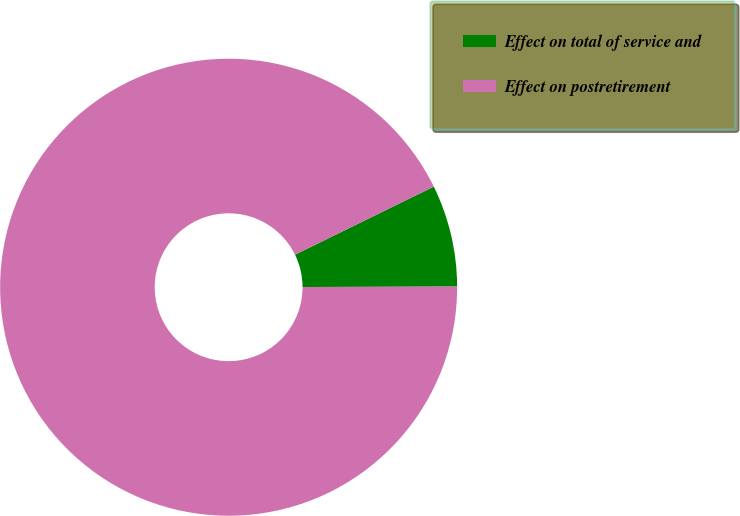Convert chart. <chart><loc_0><loc_0><loc_500><loc_500><pie_chart><fcel>Effect on total of service and<fcel>Effect on postretirement<nl><fcel>7.21%<fcel>92.79%<nl></chart> 